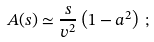Convert formula to latex. <formula><loc_0><loc_0><loc_500><loc_500>A ( s ) \simeq \frac { s } { v ^ { 2 } } \left ( 1 - a ^ { 2 } \right ) \, ;</formula> 